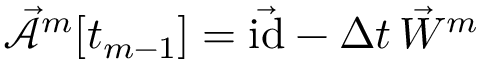Convert formula to latex. <formula><loc_0><loc_0><loc_500><loc_500>\mathcal { \vec { A } } ^ { m } [ t _ { m - 1 } ] = \vec { i d } - \Delta t \, \vec { W } ^ { m }</formula> 